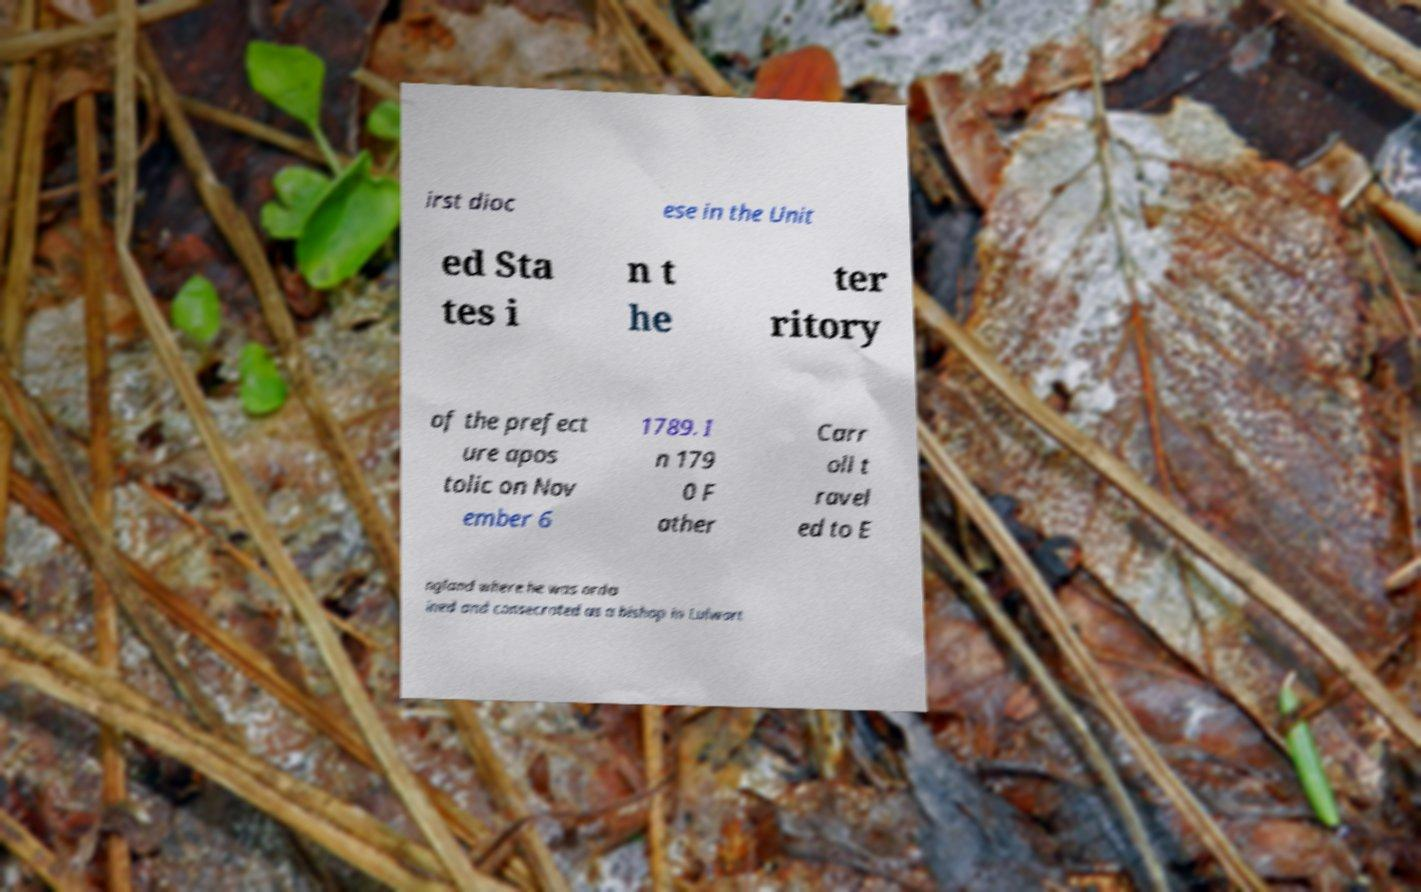For documentation purposes, I need the text within this image transcribed. Could you provide that? irst dioc ese in the Unit ed Sta tes i n t he ter ritory of the prefect ure apos tolic on Nov ember 6 1789. I n 179 0 F ather Carr oll t ravel ed to E ngland where he was orda ined and consecrated as a bishop in Lulwort 